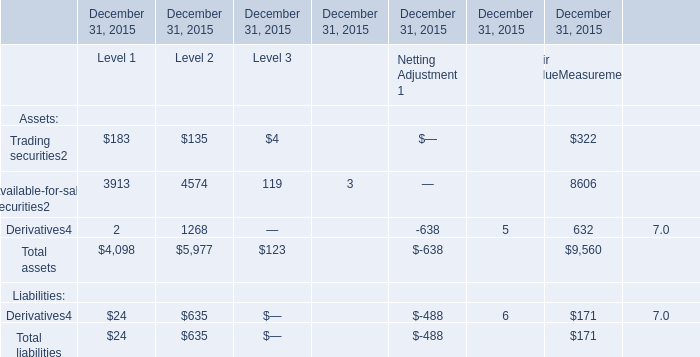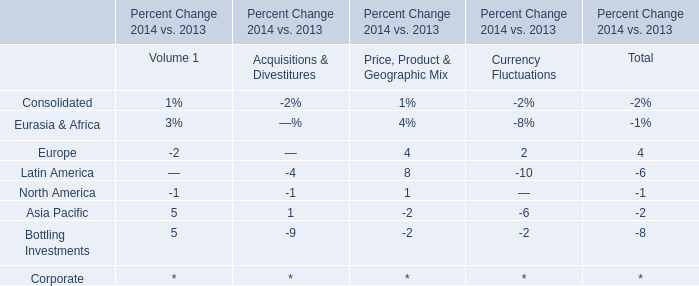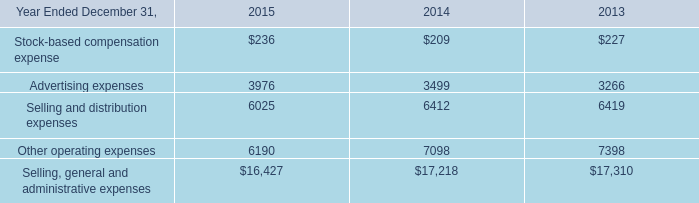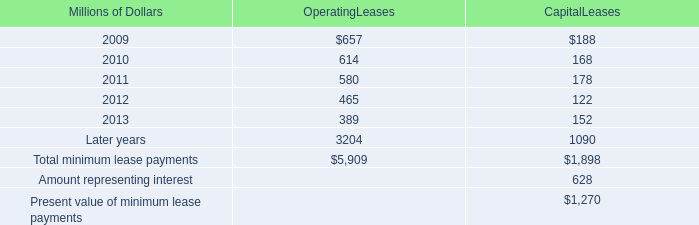What is the sum of Other operating expenses of 2014, Derivatives of December 31, 2015 Level 2, and Total assets of December 31, 2015 Level 2 ? 
Computations: ((7098.0 + 1268.0) + 5977.0)
Answer: 14343.0. 